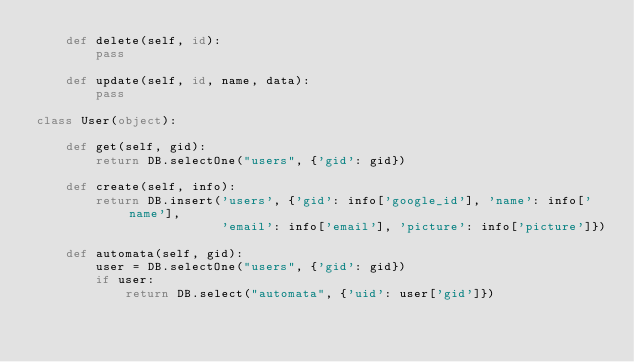Convert code to text. <code><loc_0><loc_0><loc_500><loc_500><_Python_>    def delete(self, id):
        pass

    def update(self, id, name, data):
        pass

class User(object):

    def get(self, gid):
        return DB.selectOne("users", {'gid': gid})

    def create(self, info):
        return DB.insert('users', {'gid': info['google_id'], 'name': info['name'],
                         'email': info['email'], 'picture': info['picture']})

    def automata(self, gid):
        user = DB.selectOne("users", {'gid': gid})
        if user:
            return DB.select("automata", {'uid': user['gid']})
</code> 